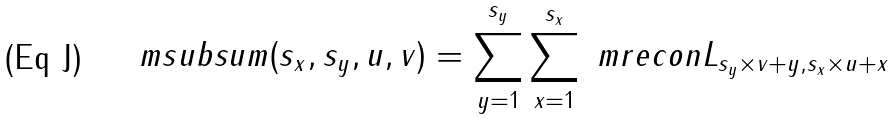Convert formula to latex. <formula><loc_0><loc_0><loc_500><loc_500>\ m s u b s u m ( s _ { x } , s _ { y } , u , v ) = \sum _ { y = 1 } ^ { s _ { y } } \sum _ { x = 1 } ^ { s _ { x } } \ m r e c o n { L } _ { s _ { y } \times v + y , s _ { x } \times u + x }</formula> 